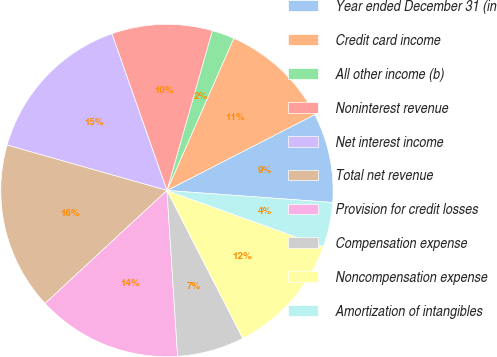Convert chart. <chart><loc_0><loc_0><loc_500><loc_500><pie_chart><fcel>Year ended December 31 (in<fcel>Credit card income<fcel>All other income (b)<fcel>Noninterest revenue<fcel>Net interest income<fcel>Total net revenue<fcel>Provision for credit losses<fcel>Compensation expense<fcel>Noncompensation expense<fcel>Amortization of intangibles<nl><fcel>8.7%<fcel>10.87%<fcel>2.18%<fcel>9.78%<fcel>15.22%<fcel>16.3%<fcel>14.13%<fcel>6.52%<fcel>11.96%<fcel>4.35%<nl></chart> 